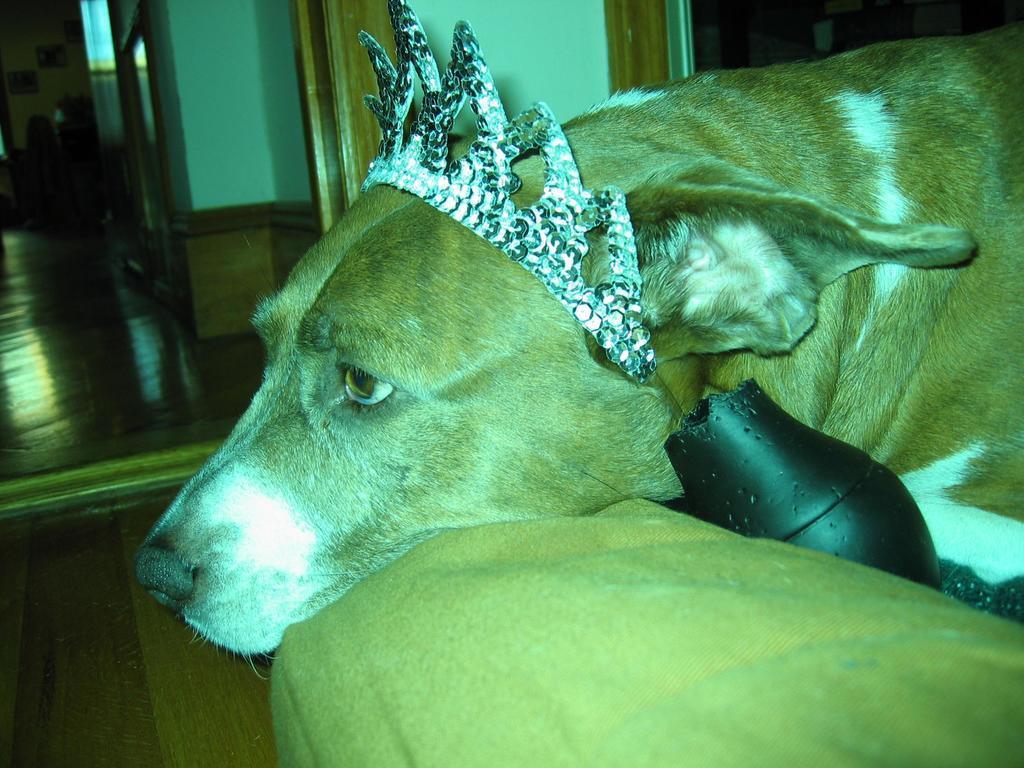Describe this image in one or two sentences. In this image on the right side, I can see a dog. In the background, I can see the photo frames on the wall. 